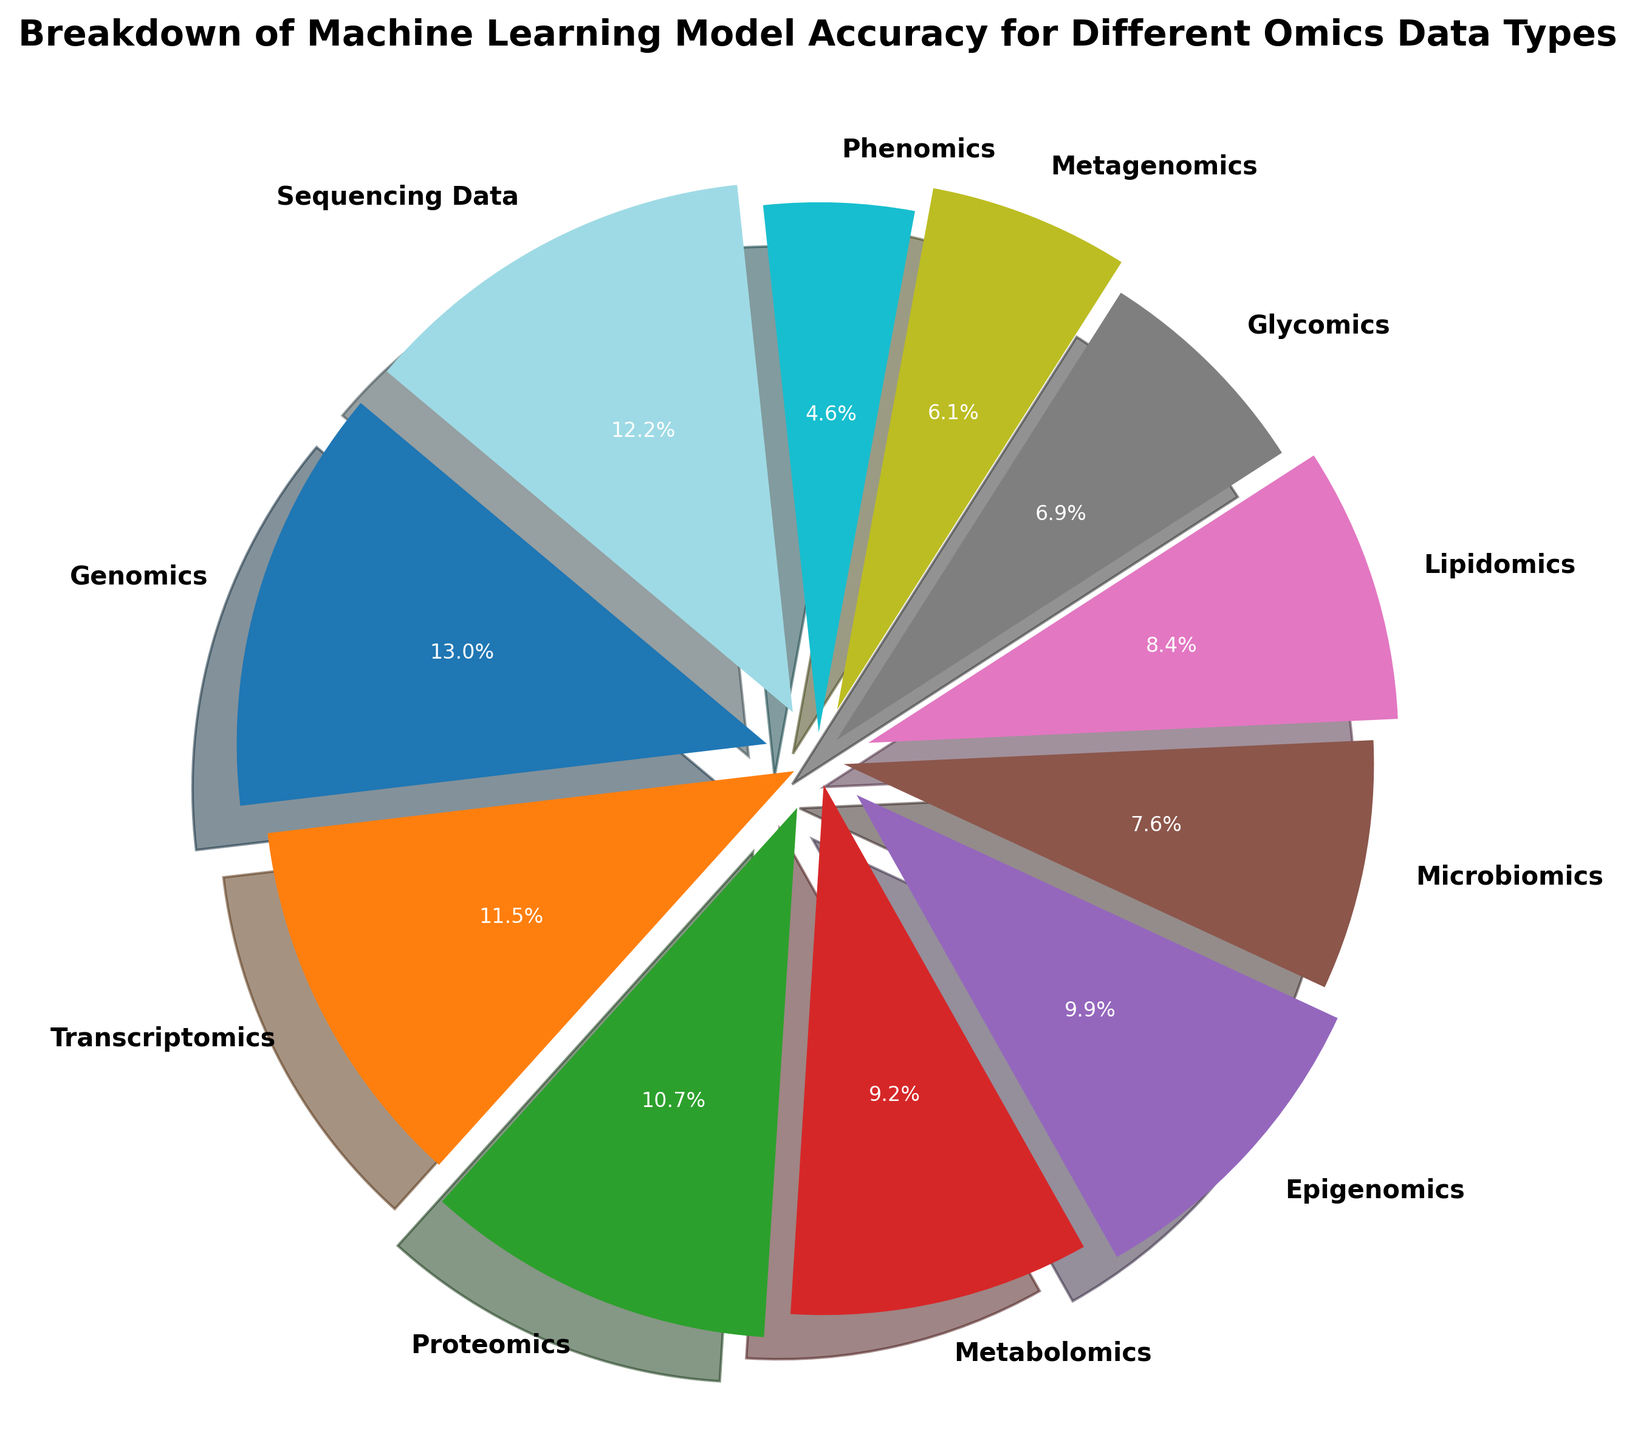What is the accuracy percentage for Genomics? The accuracy for Genomics can be directly read from the figure where it's explicitly marked.
Answer: 85% Which omics data type has the lowest model accuracy? The figure has various percentage points displayed. The one with the smallest value is the lowest model accuracy, which in this case is Phenomics.
Answer: Phenomics What is the difference in model accuracy between Sequencing Data and Proteomics? To find the difference, subtract Proteomics' accuracy from Sequencing Data's accuracy (80% - 70% = 10%).
Answer: 10% Which omics data types have accuracy percentages greater than 70%? From the pie chart, we identify the types exceeding 70% by reading the percentage values directly off the figure (Genomics, Sequencing Data, Transcriptomics).
Answer: Genomics, Sequencing Data, Transcriptomics How does the accuracy of Metagenomics compare to that of Transcriptomics? Compare the percentage values directly from the figure. Metagenomics has 40% accuracy, while Transcriptomics has 75% accuracy.
Answer: Metagenomics is 35% lower than Transcriptomics What is the sum of the model accuracies for Glycomics, Lipidomics, and Epigenomics? Combine the percentages by adding the values directly shown in the figure (45% + 55% + 65% = 165%).
Answer: 165% What is the average accuracy percentage of all listed omics data types? Sum all the percentage values and divide by the total number of data types (85 + 75 + 70 + 60 + 65 + 50 + 55 + 45 + 40 + 30 + 80) / 11. The sum is 655; divide by 11 to get the average: \(\frac{655}{11} \approx 59.5\).
Answer: 59.5% What is the difference in accuracy percentage between the highest and the lowest data types? Subtract the lowest accuracy (Phenomics, 30%) from the highest (Genomics, 85%) value, 85% - 30% = 55%.
Answer: 55% Which data type is represented by the largest wedge? The size of the wedge is proportional to the percentage; thus, the largest wedge corresponds to Genomics with the highest percentage (85%).
Answer: Genomics Are there any omics data types with accuracy percentages close to each other within a 5% range? Look for values among the data points that are numerically close. Lipidomics (55%) and Microbiomics (50%) fall within a 5% range.
Answer: Lipidomics and Microbiomics 